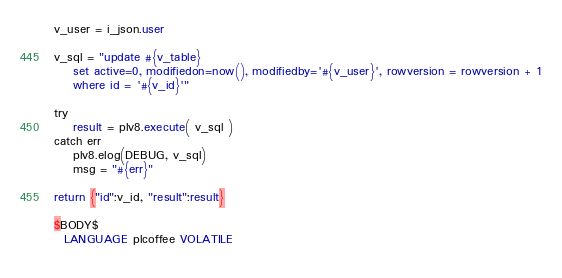Convert code to text. <code><loc_0><loc_0><loc_500><loc_500><_SQL_>v_user = i_json.user

v_sql = "update #{v_table}
    set active=0, modifiedon=now(), modifiedby='#{v_user}', rowversion = rowversion + 1
    where id = '#{v_id}'"

try
    result = plv8.execute( v_sql )
catch err
    plv8.elog(DEBUG, v_sql)
    msg = "#{err}"

return {"id":v_id, "result":result}

$BODY$
  LANGUAGE plcoffee VOLATILE
  </code> 